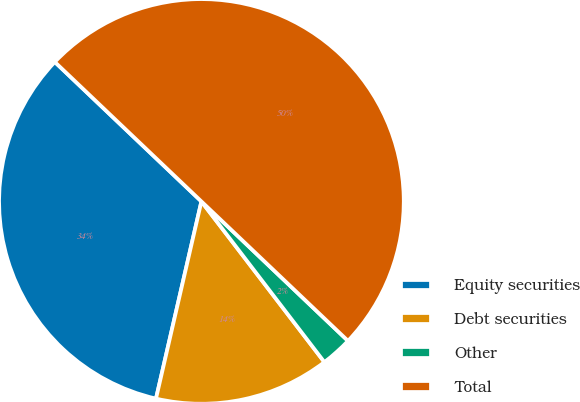Convert chart to OTSL. <chart><loc_0><loc_0><loc_500><loc_500><pie_chart><fcel>Equity securities<fcel>Debt securities<fcel>Other<fcel>Total<nl><fcel>33.5%<fcel>14.0%<fcel>2.5%<fcel>50.0%<nl></chart> 